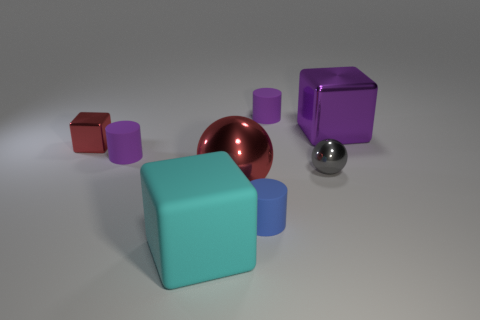Are there any tiny blue cylinders?
Ensure brevity in your answer.  Yes. What is the color of the small rubber cylinder that is behind the big cube that is behind the small shiny sphere?
Offer a terse response. Purple. What material is the gray thing that is the same shape as the large red thing?
Offer a very short reply. Metal. What number of red metal balls are the same size as the gray shiny sphere?
Make the answer very short. 0. There is a gray sphere that is the same material as the large red thing; what size is it?
Your answer should be compact. Small. What number of gray metal things have the same shape as the big cyan thing?
Make the answer very short. 0. What number of small brown blocks are there?
Provide a succinct answer. 0. There is a large red metallic object on the left side of the gray sphere; is its shape the same as the big purple thing?
Your answer should be very brief. No. There is a purple block that is the same size as the cyan rubber object; what is its material?
Your answer should be compact. Metal. Are there any blue things that have the same material as the large cyan block?
Your response must be concise. Yes. 